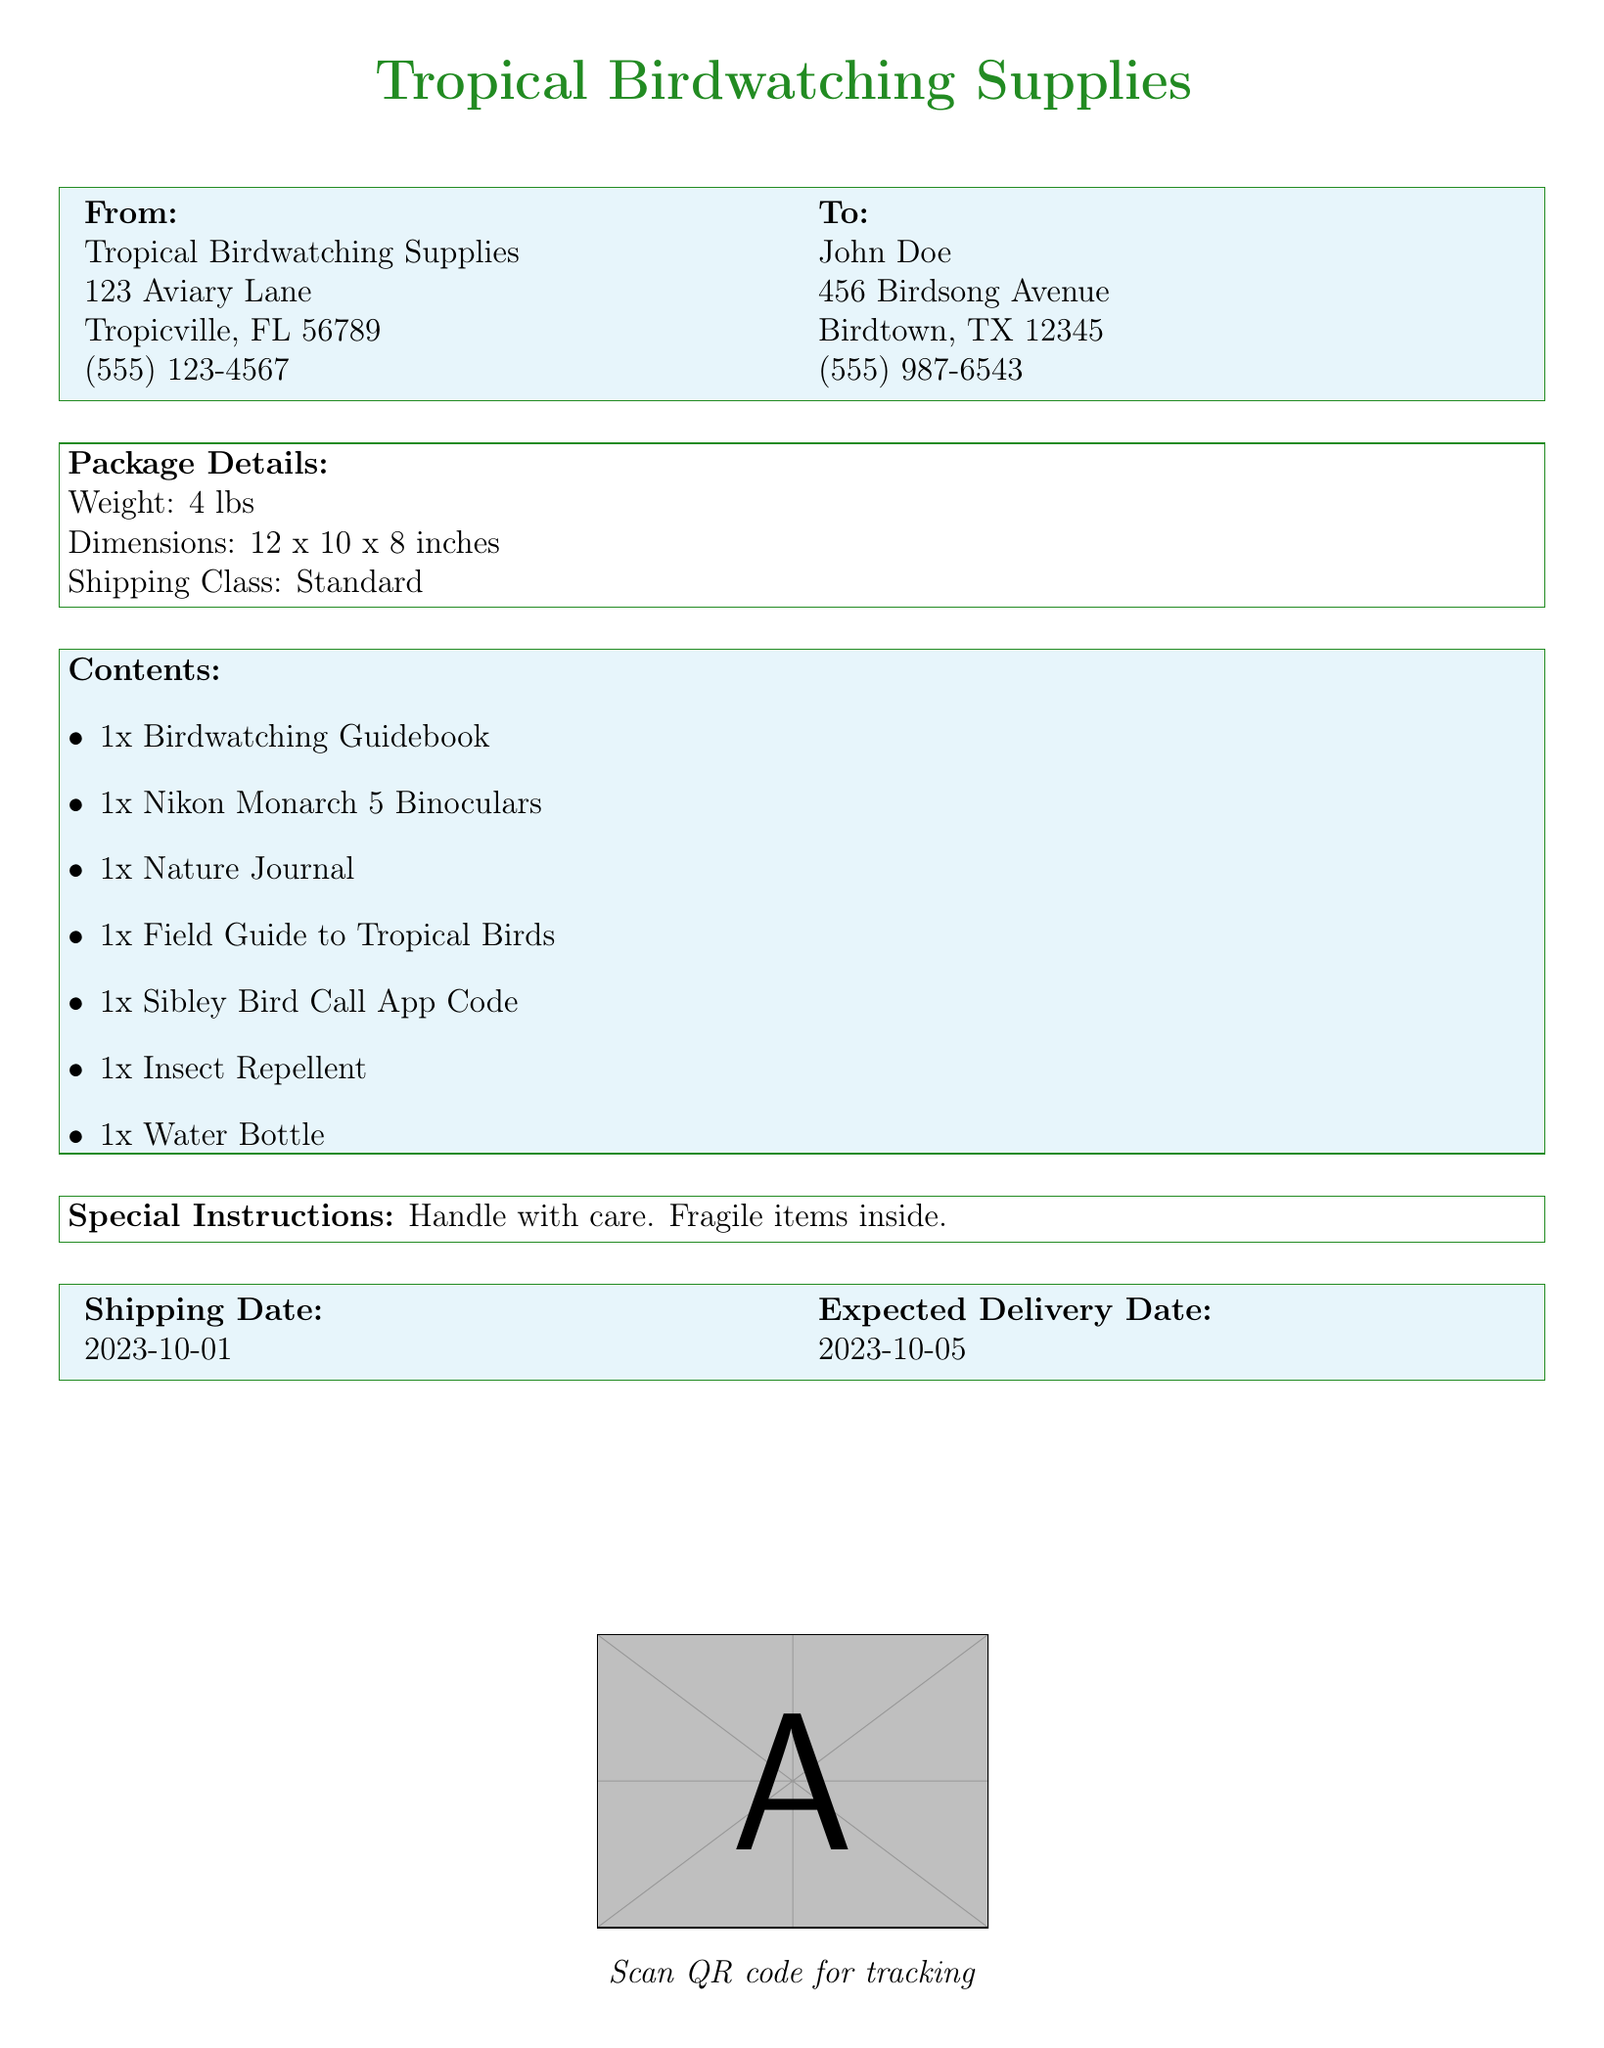What is the sender's name? The sender's name is stated in the "From" section of the document.
Answer: Tropical Birdwatching Supplies What is the recipient's address? The recipient's full address is listed in the "To" section of the document.
Answer: 456 Birdsong Avenue, Birdtown, TX 12345 What is the weight of the package? The weight of the package is mentioned in the "Package Details" section.
Answer: 4 lbs What is included in the contents? The contents of the package are listed in the "Contents" section with various items.
Answer: 1x Birdwatching Guidebook What is the shipping date? The shipping date is highlighted in the "Shipping Date" section of the document.
Answer: 2023-10-01 What special instructions are provided? Special instructions for handling the package are outlined in the relevant section.
Answer: Handle with care. Fragile items inside How many items are listed in the contents? The total items in the "Contents" section can be tallied.
Answer: 7 items What colors are used in the box headers? The colors used in the box headers are described in the document’s design elements.
Answer: Tropical green and sky blue When is the expected delivery date? The expected delivery date is specified in the "Expected Delivery Date" section.
Answer: 2023-10-05 